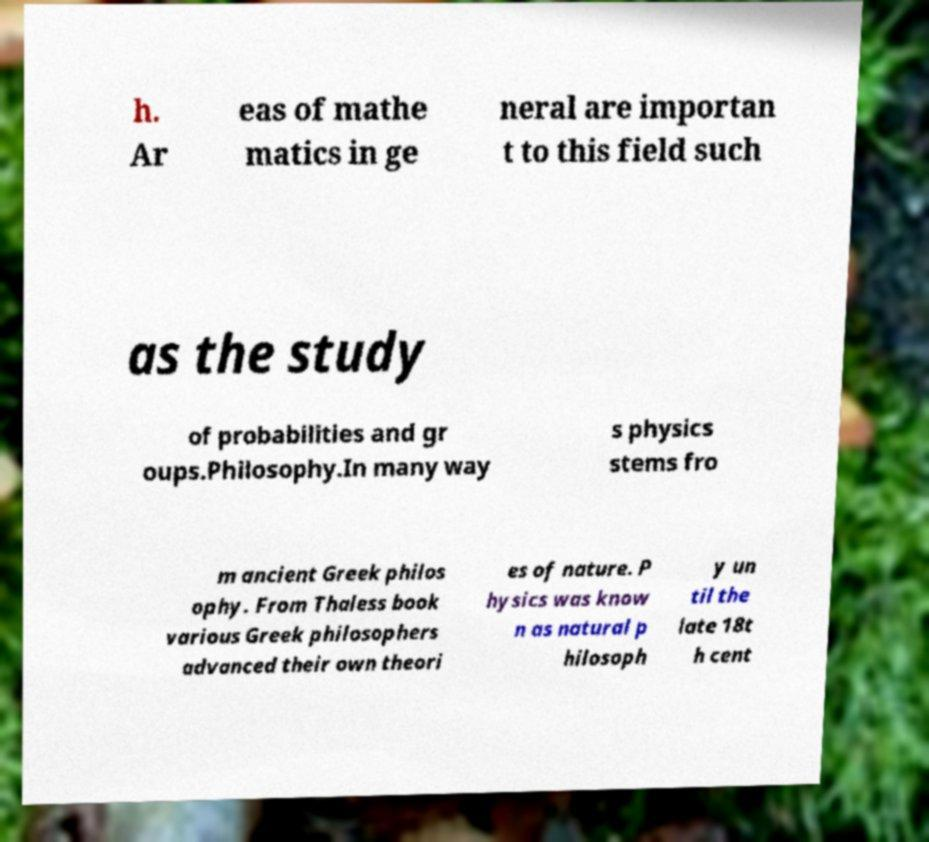There's text embedded in this image that I need extracted. Can you transcribe it verbatim? h. Ar eas of mathe matics in ge neral are importan t to this field such as the study of probabilities and gr oups.Philosophy.In many way s physics stems fro m ancient Greek philos ophy. From Thaless book various Greek philosophers advanced their own theori es of nature. P hysics was know n as natural p hilosoph y un til the late 18t h cent 